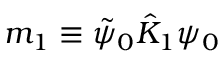<formula> <loc_0><loc_0><loc_500><loc_500>m _ { 1 } \equiv \tilde { \psi } _ { 0 } \hat { K } _ { 1 } \psi _ { 0 }</formula> 